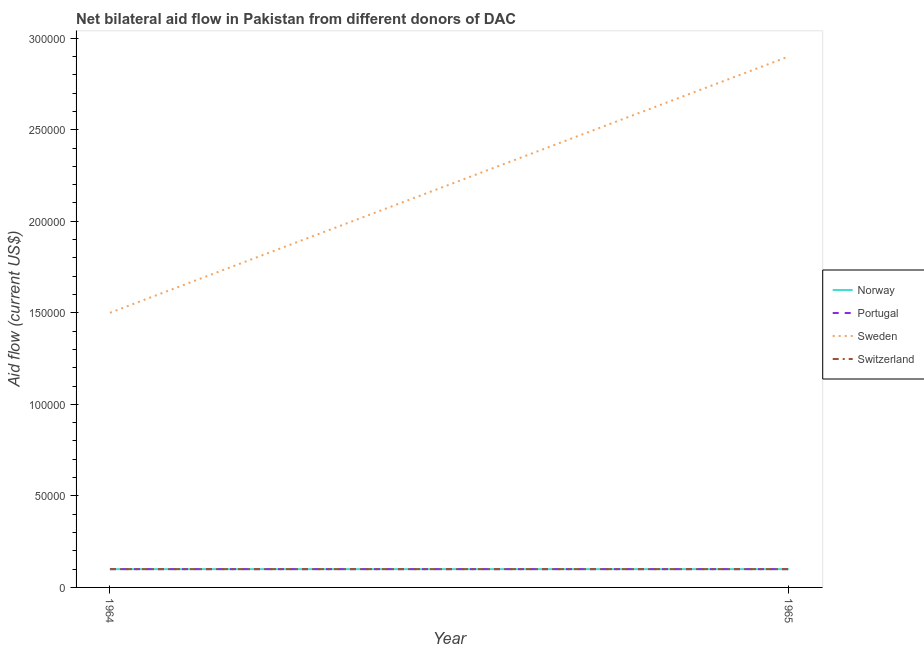Does the line corresponding to amount of aid given by norway intersect with the line corresponding to amount of aid given by switzerland?
Your answer should be compact. Yes. Is the number of lines equal to the number of legend labels?
Offer a very short reply. Yes. What is the amount of aid given by sweden in 1964?
Your answer should be very brief. 1.50e+05. Across all years, what is the maximum amount of aid given by switzerland?
Provide a short and direct response. 10000. Across all years, what is the minimum amount of aid given by sweden?
Offer a terse response. 1.50e+05. In which year was the amount of aid given by sweden maximum?
Your response must be concise. 1965. In which year was the amount of aid given by norway minimum?
Offer a terse response. 1964. What is the total amount of aid given by portugal in the graph?
Offer a terse response. 2.00e+04. What is the difference between the amount of aid given by sweden in 1964 and that in 1965?
Your response must be concise. -1.40e+05. What is the difference between the amount of aid given by switzerland in 1965 and the amount of aid given by portugal in 1964?
Your answer should be very brief. 0. What is the average amount of aid given by sweden per year?
Your response must be concise. 2.20e+05. In the year 1964, what is the difference between the amount of aid given by switzerland and amount of aid given by sweden?
Your answer should be very brief. -1.40e+05. What is the ratio of the amount of aid given by sweden in 1964 to that in 1965?
Make the answer very short. 0.52. Is the amount of aid given by portugal in 1964 less than that in 1965?
Ensure brevity in your answer.  No. In how many years, is the amount of aid given by portugal greater than the average amount of aid given by portugal taken over all years?
Your response must be concise. 0. Is it the case that in every year, the sum of the amount of aid given by norway and amount of aid given by portugal is greater than the amount of aid given by sweden?
Provide a short and direct response. No. Is the amount of aid given by portugal strictly greater than the amount of aid given by norway over the years?
Your response must be concise. No. Is the amount of aid given by norway strictly less than the amount of aid given by sweden over the years?
Ensure brevity in your answer.  Yes. How many lines are there?
Your response must be concise. 4. What is the difference between two consecutive major ticks on the Y-axis?
Your response must be concise. 5.00e+04. Does the graph contain any zero values?
Make the answer very short. No. Where does the legend appear in the graph?
Provide a succinct answer. Center right. How many legend labels are there?
Make the answer very short. 4. How are the legend labels stacked?
Give a very brief answer. Vertical. What is the title of the graph?
Provide a short and direct response. Net bilateral aid flow in Pakistan from different donors of DAC. What is the label or title of the X-axis?
Your response must be concise. Year. What is the Aid flow (current US$) of Norway in 1964?
Your answer should be compact. 10000. What is the Aid flow (current US$) in Portugal in 1964?
Your answer should be compact. 10000. What is the Aid flow (current US$) of Switzerland in 1964?
Provide a succinct answer. 10000. What is the Aid flow (current US$) in Norway in 1965?
Provide a succinct answer. 10000. What is the Aid flow (current US$) in Portugal in 1965?
Offer a terse response. 10000. Across all years, what is the maximum Aid flow (current US$) of Norway?
Your answer should be compact. 10000. Across all years, what is the maximum Aid flow (current US$) in Portugal?
Make the answer very short. 10000. Across all years, what is the maximum Aid flow (current US$) in Sweden?
Offer a terse response. 2.90e+05. Across all years, what is the minimum Aid flow (current US$) of Norway?
Give a very brief answer. 10000. Across all years, what is the minimum Aid flow (current US$) of Switzerland?
Give a very brief answer. 10000. What is the total Aid flow (current US$) in Sweden in the graph?
Keep it short and to the point. 4.40e+05. What is the difference between the Aid flow (current US$) in Norway in 1964 and that in 1965?
Provide a short and direct response. 0. What is the difference between the Aid flow (current US$) of Norway in 1964 and the Aid flow (current US$) of Sweden in 1965?
Your answer should be very brief. -2.80e+05. What is the difference between the Aid flow (current US$) in Norway in 1964 and the Aid flow (current US$) in Switzerland in 1965?
Keep it short and to the point. 0. What is the difference between the Aid flow (current US$) of Portugal in 1964 and the Aid flow (current US$) of Sweden in 1965?
Offer a very short reply. -2.80e+05. What is the difference between the Aid flow (current US$) of Sweden in 1964 and the Aid flow (current US$) of Switzerland in 1965?
Give a very brief answer. 1.40e+05. What is the average Aid flow (current US$) in Portugal per year?
Give a very brief answer. 10000. What is the average Aid flow (current US$) of Sweden per year?
Offer a terse response. 2.20e+05. In the year 1964, what is the difference between the Aid flow (current US$) of Norway and Aid flow (current US$) of Portugal?
Provide a short and direct response. 0. In the year 1964, what is the difference between the Aid flow (current US$) in Norway and Aid flow (current US$) in Switzerland?
Give a very brief answer. 0. In the year 1964, what is the difference between the Aid flow (current US$) of Portugal and Aid flow (current US$) of Sweden?
Offer a very short reply. -1.40e+05. In the year 1964, what is the difference between the Aid flow (current US$) of Portugal and Aid flow (current US$) of Switzerland?
Your answer should be very brief. 0. In the year 1964, what is the difference between the Aid flow (current US$) in Sweden and Aid flow (current US$) in Switzerland?
Make the answer very short. 1.40e+05. In the year 1965, what is the difference between the Aid flow (current US$) of Norway and Aid flow (current US$) of Portugal?
Your answer should be very brief. 0. In the year 1965, what is the difference between the Aid flow (current US$) of Norway and Aid flow (current US$) of Sweden?
Make the answer very short. -2.80e+05. In the year 1965, what is the difference between the Aid flow (current US$) of Portugal and Aid flow (current US$) of Sweden?
Provide a short and direct response. -2.80e+05. In the year 1965, what is the difference between the Aid flow (current US$) of Sweden and Aid flow (current US$) of Switzerland?
Your response must be concise. 2.80e+05. What is the ratio of the Aid flow (current US$) in Norway in 1964 to that in 1965?
Your answer should be very brief. 1. What is the ratio of the Aid flow (current US$) in Portugal in 1964 to that in 1965?
Offer a terse response. 1. What is the ratio of the Aid flow (current US$) in Sweden in 1964 to that in 1965?
Provide a succinct answer. 0.52. 